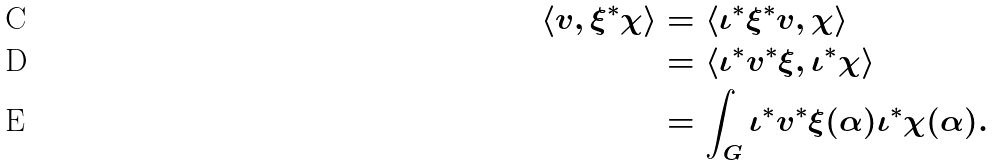<formula> <loc_0><loc_0><loc_500><loc_500>\langle v , \xi ^ { * } \chi \rangle & = \langle \iota ^ { * } \xi ^ { * } v , \chi \rangle \\ & = \langle \iota ^ { * } v ^ { * } \xi , \iota ^ { * } \chi \rangle \\ & = \int _ { G } \iota ^ { * } v ^ { * } \xi ( \alpha ) \iota ^ { * } \chi ( \alpha ) .</formula> 